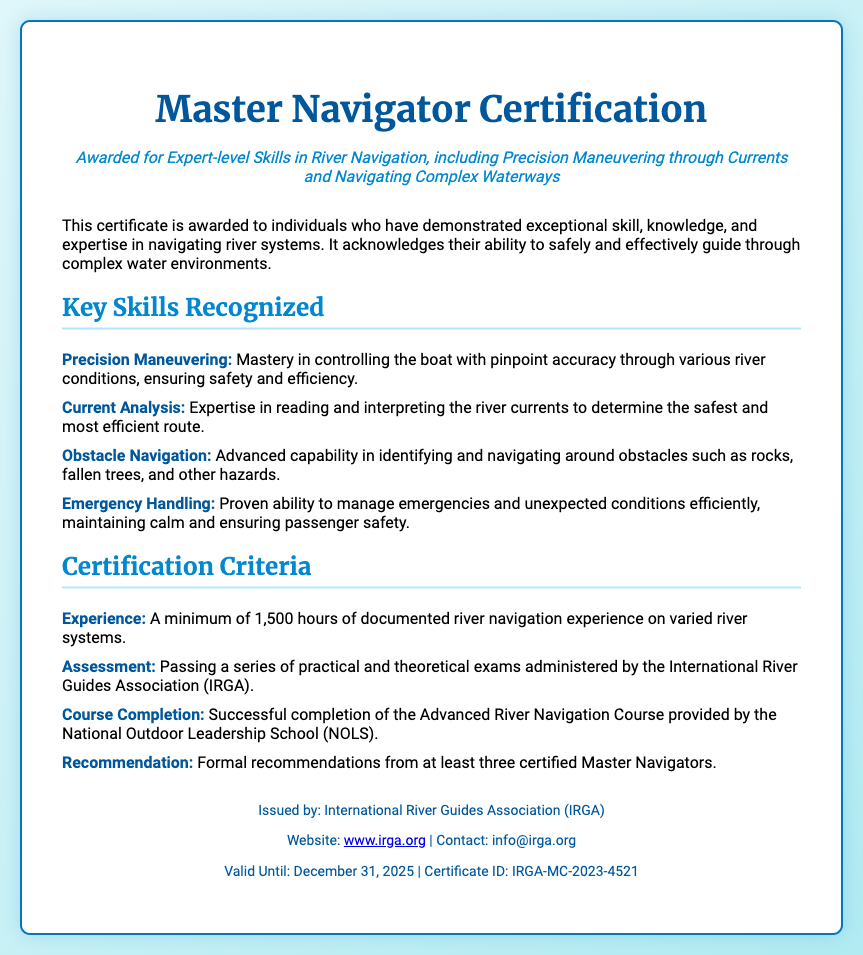what is the title of the certification? The title of the certification is prominently displayed at the top of the document.
Answer: Master Navigator Certification who issued the certification? The issuing organization is mentioned in the footer of the document.
Answer: International River Guides Association (IRGA) what is the minimum documented river navigation experience required? The document specifies the experience requirement in the criteria section.
Answer: 1,500 hours which course must be completed for certification? The required course is detailed in the certification criteria.
Answer: Advanced River Navigation Course what is the validity period of the certificate? The validity period is outlined in the footer of the document.
Answer: December 31, 2025 how many recommendations are required from certified Master Navigators? The document details the recommendation requirement in the criteria section.
Answer: Three what skill is recognized for managing emergencies? The skill related to handling emergencies is listed under key skills.
Answer: Emergency Handling what organization administers the assessments? The administering organization for the assessments is mentioned in the certification criteria.
Answer: International River Guides Association (IRGA) what color is used for the header font? The color of the header font is specified in the style definition.
Answer: #01579b 